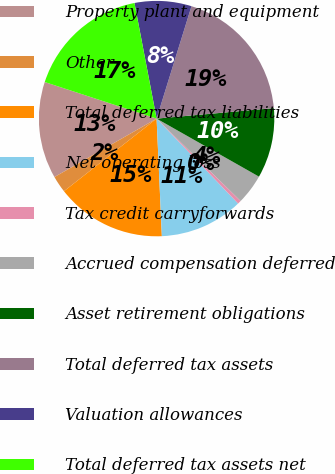Convert chart. <chart><loc_0><loc_0><loc_500><loc_500><pie_chart><fcel>Property plant and equipment<fcel>Other<fcel>Total deferred tax liabilities<fcel>Net operating loss<fcel>Tax credit carryforwards<fcel>Accrued compensation deferred<fcel>Asset retirement obligations<fcel>Total deferred tax assets<fcel>Valuation allowances<fcel>Total deferred tax assets net<nl><fcel>13.3%<fcel>2.31%<fcel>15.13%<fcel>11.46%<fcel>0.48%<fcel>4.14%<fcel>9.63%<fcel>18.79%<fcel>7.8%<fcel>16.96%<nl></chart> 